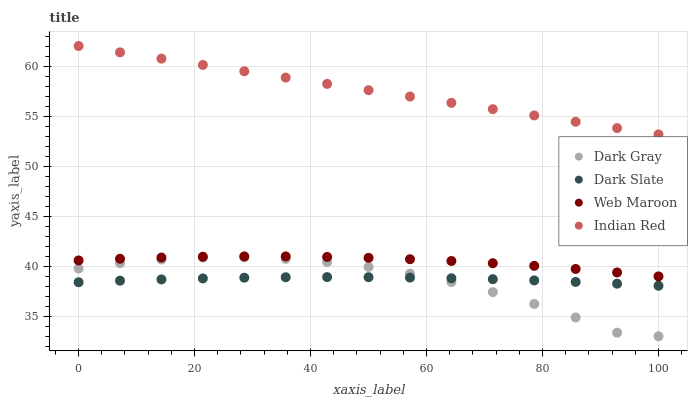Does Dark Gray have the minimum area under the curve?
Answer yes or no. Yes. Does Indian Red have the maximum area under the curve?
Answer yes or no. Yes. Does Dark Slate have the minimum area under the curve?
Answer yes or no. No. Does Dark Slate have the maximum area under the curve?
Answer yes or no. No. Is Indian Red the smoothest?
Answer yes or no. Yes. Is Dark Gray the roughest?
Answer yes or no. Yes. Is Dark Slate the smoothest?
Answer yes or no. No. Is Dark Slate the roughest?
Answer yes or no. No. Does Dark Gray have the lowest value?
Answer yes or no. Yes. Does Dark Slate have the lowest value?
Answer yes or no. No. Does Indian Red have the highest value?
Answer yes or no. Yes. Does Web Maroon have the highest value?
Answer yes or no. No. Is Dark Slate less than Web Maroon?
Answer yes or no. Yes. Is Indian Red greater than Web Maroon?
Answer yes or no. Yes. Does Dark Slate intersect Dark Gray?
Answer yes or no. Yes. Is Dark Slate less than Dark Gray?
Answer yes or no. No. Is Dark Slate greater than Dark Gray?
Answer yes or no. No. Does Dark Slate intersect Web Maroon?
Answer yes or no. No. 